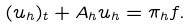Convert formula to latex. <formula><loc_0><loc_0><loc_500><loc_500>( u _ { h } ) _ { t } + A _ { h } u _ { h } = \pi _ { h } f .</formula> 